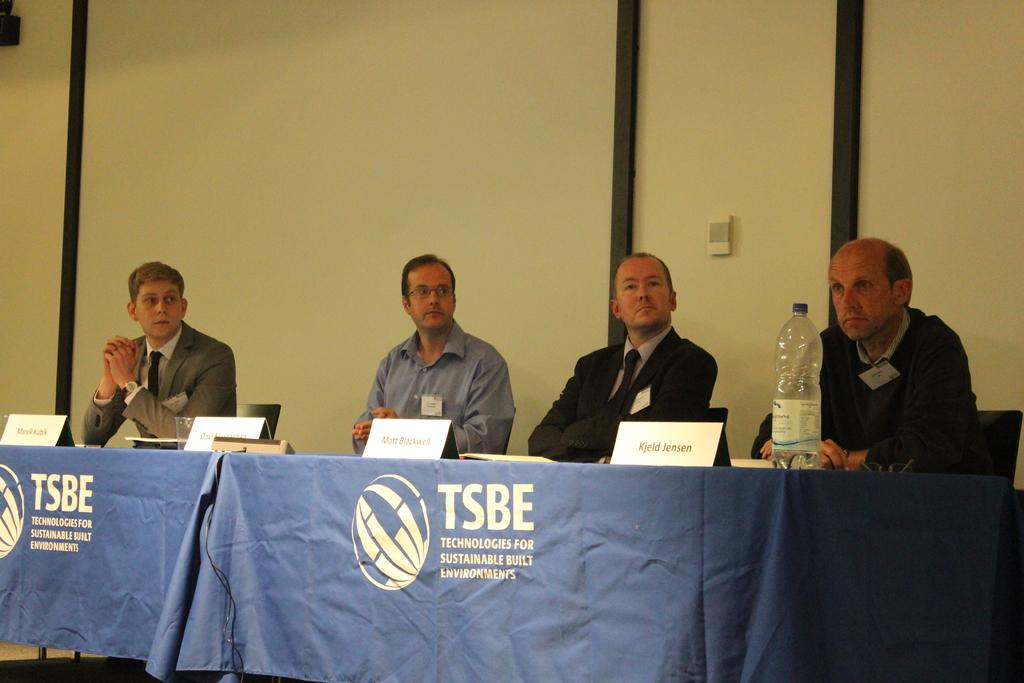What is present in the background of the image? There is a wall in the image. How many men are sitting in front of the table? There are four men sitting on chairs in front of the table. What can be seen on the table? There are name boards and a bottle on the table. What type of pizzas are being served on the table? A: There are no pizzas present in the image. What is the cause of the men sitting in front of the table? The provided facts do not give any information about the reason or cause for the men sitting in front of the table. 